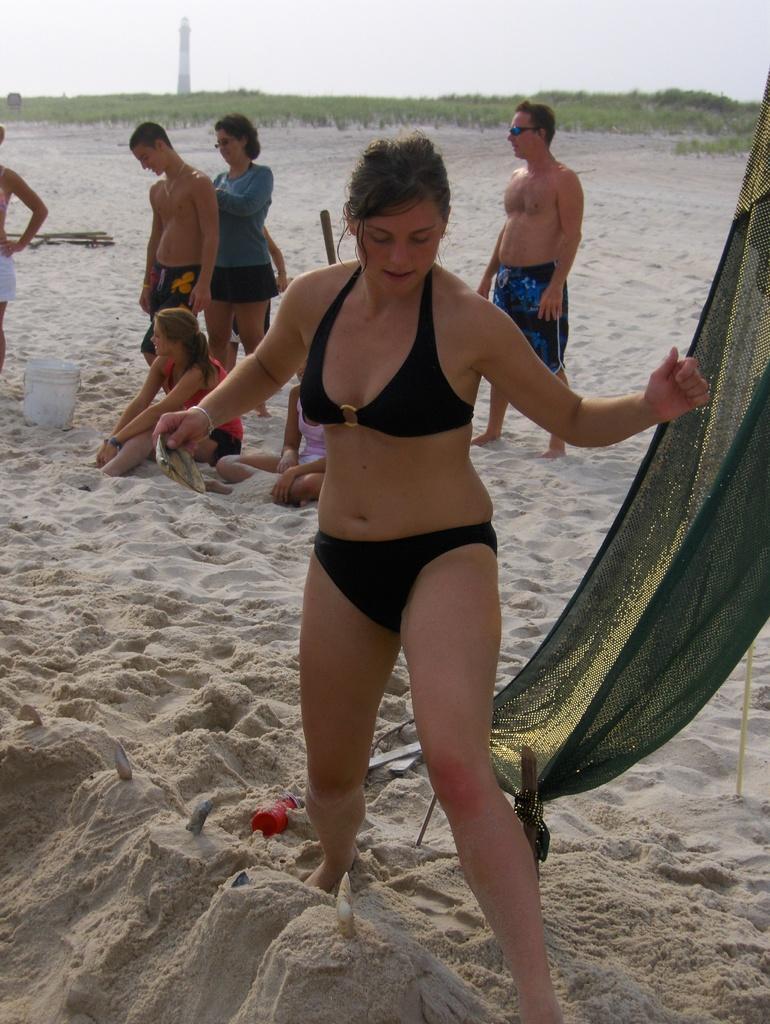Could you give a brief overview of what you see in this image? A beautiful woman is standing, she wore black color clothes. Behind her a man is standing on this sand. On the left side few people are there. 